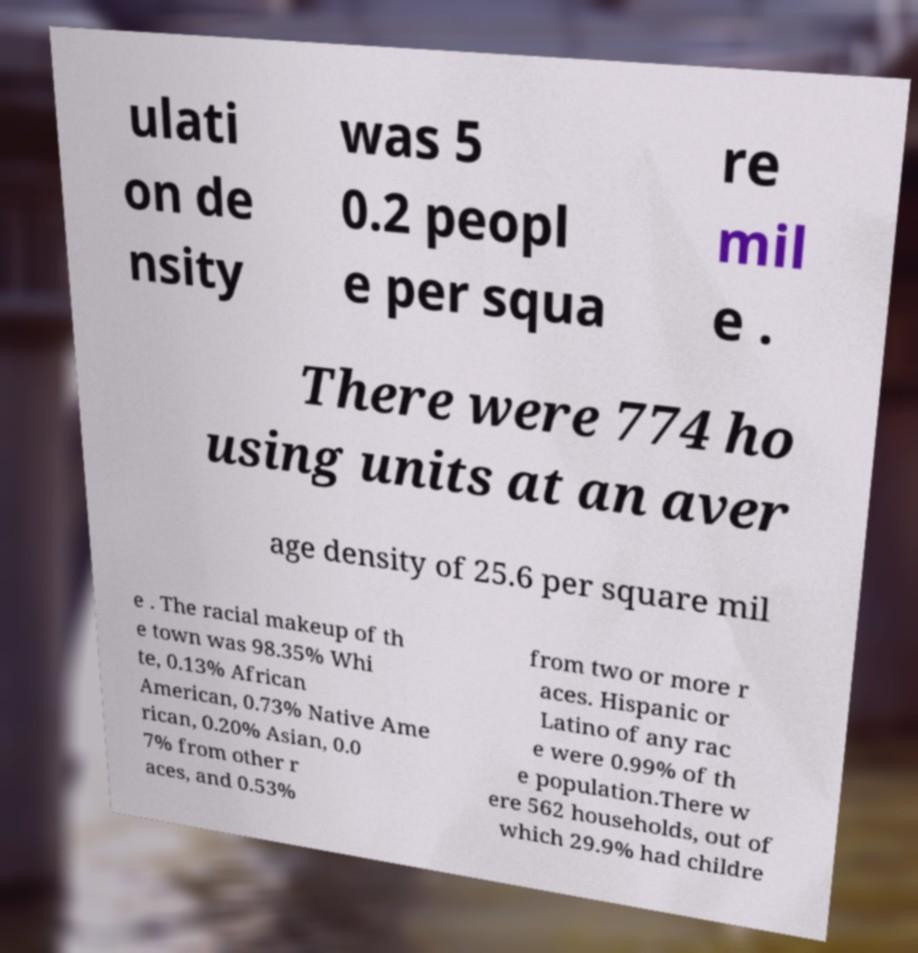For documentation purposes, I need the text within this image transcribed. Could you provide that? ulati on de nsity was 5 0.2 peopl e per squa re mil e . There were 774 ho using units at an aver age density of 25.6 per square mil e . The racial makeup of th e town was 98.35% Whi te, 0.13% African American, 0.73% Native Ame rican, 0.20% Asian, 0.0 7% from other r aces, and 0.53% from two or more r aces. Hispanic or Latino of any rac e were 0.99% of th e population.There w ere 562 households, out of which 29.9% had childre 